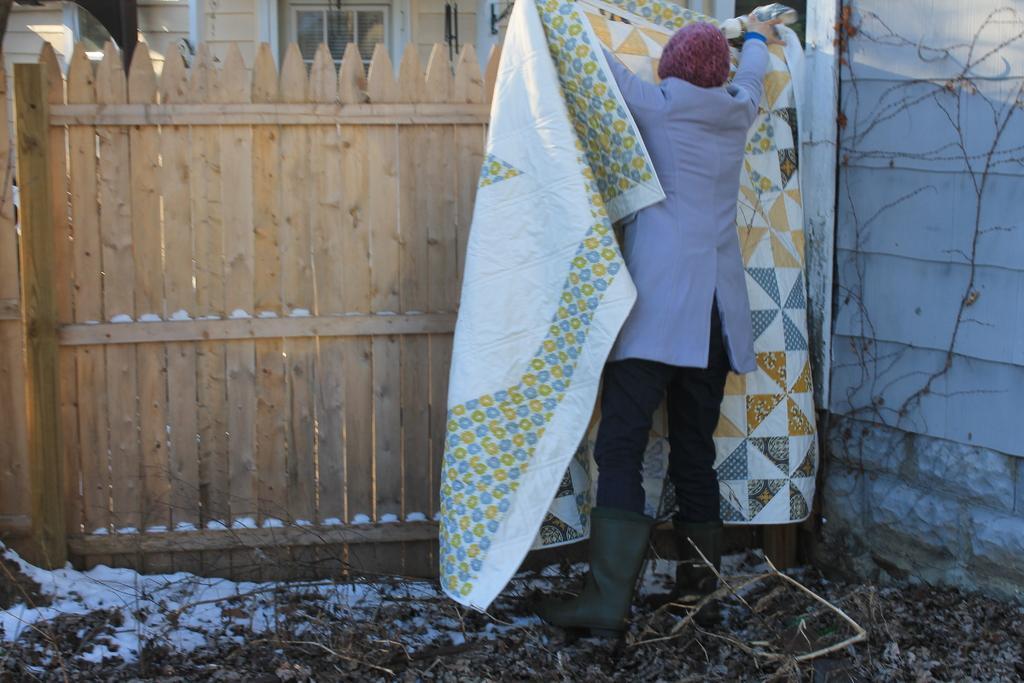Please provide a concise description of this image. In this image we can see a person wearing dress and cap is holding a cloth in his hand. In the background, we can see a fence and a building. 